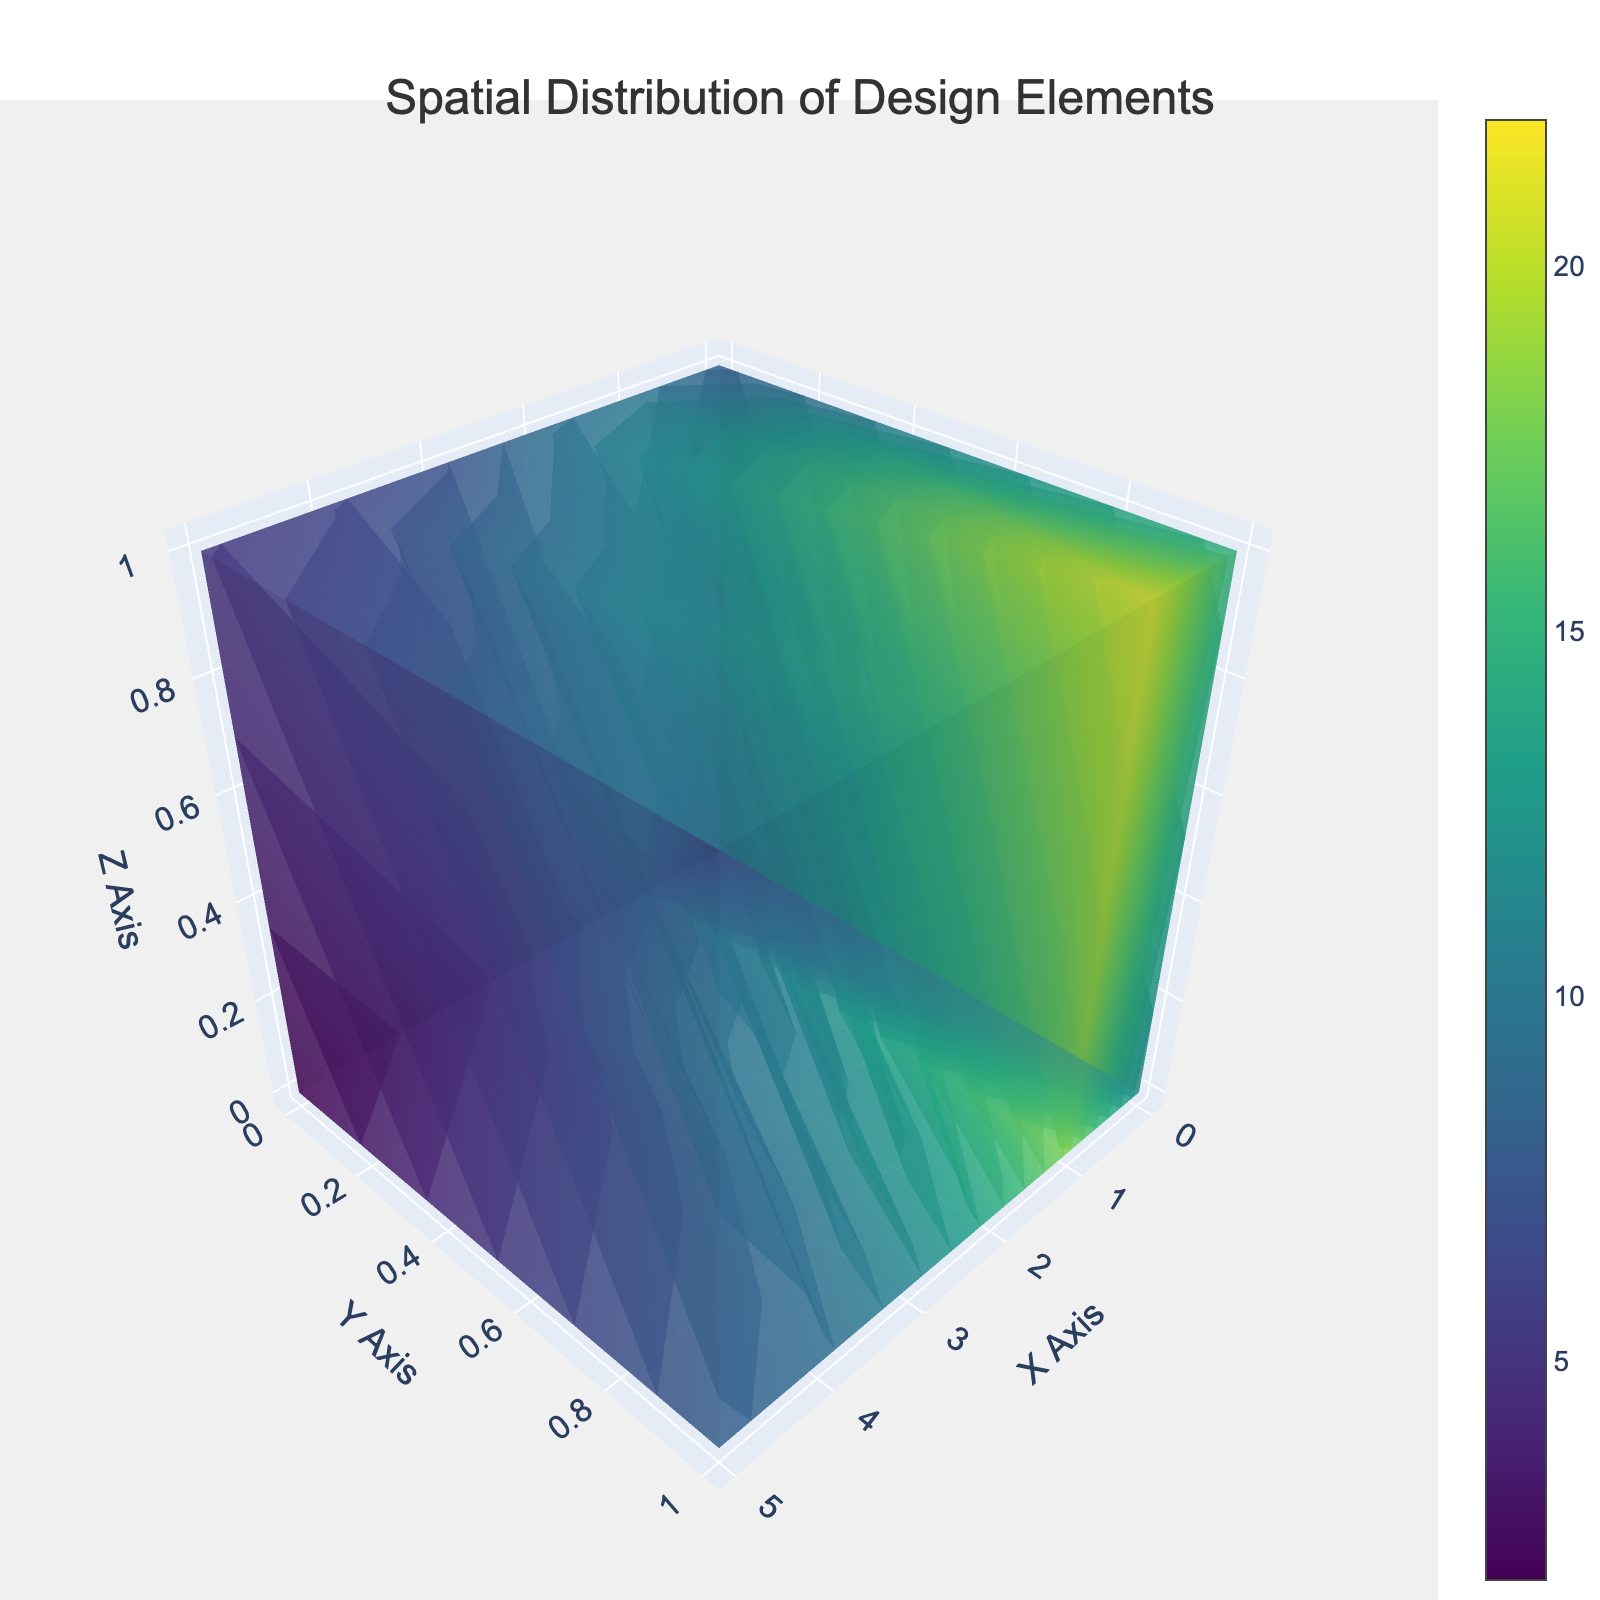What is the title of the figure? The title is centered at the top and reads "Spatial Distribution of Design Elements".
Answer: Spatial Distribution of Design Elements What does the color scale represent in the plot? The color scale represents the value associated with each data point, with different values shown in varying colors from the Viridis color scale.
Answer: Value Which axis represents the Y direction? The Y direction is indicated by the axis labeled "Y Axis" which includes a title font size of 18 from the Arial family.
Answer: Y Axis How many unique x-values are present in the plot? The x-values range from 0 to 5, indicating there are 6 unique x-values in total.
Answer: 6 What's the maximum value shown in the plot? The data point with coordinates (1,1,1) has the highest value of 22, which is represented by a deeper color.
Answer: 22 How does the value trend change along the X-axis? As the X value increases from 0 to 5, the corresponding values generally decrease in each fixed y, z plane as visually depicted by the color gradient.
Answer: Decreases Which axis contains the highest value and what is the coordinate? The highest value of 22 is found on the z-axis at the coordinate (1,1,1).
Answer: Z Axis, (1,1,1) What's the difference between the highest value and the lowest value? The highest value is 22 and the lowest value is 2, the difference between them is 22 - 2 = 20.
Answer: 20 Compare the values at coordinates (0,1,1) and (4,1,1). Which is larger? The value at (0,1,1) is 15, whereas at (4,1,1) it is 13. Therefore, 15 is larger than 13.
Answer: (0,1,1) Which iso-surface count is chosen for the volume plot? The iso-surface count set in the plot is 20, which defines the number of contour surfaces.
Answer: 20 